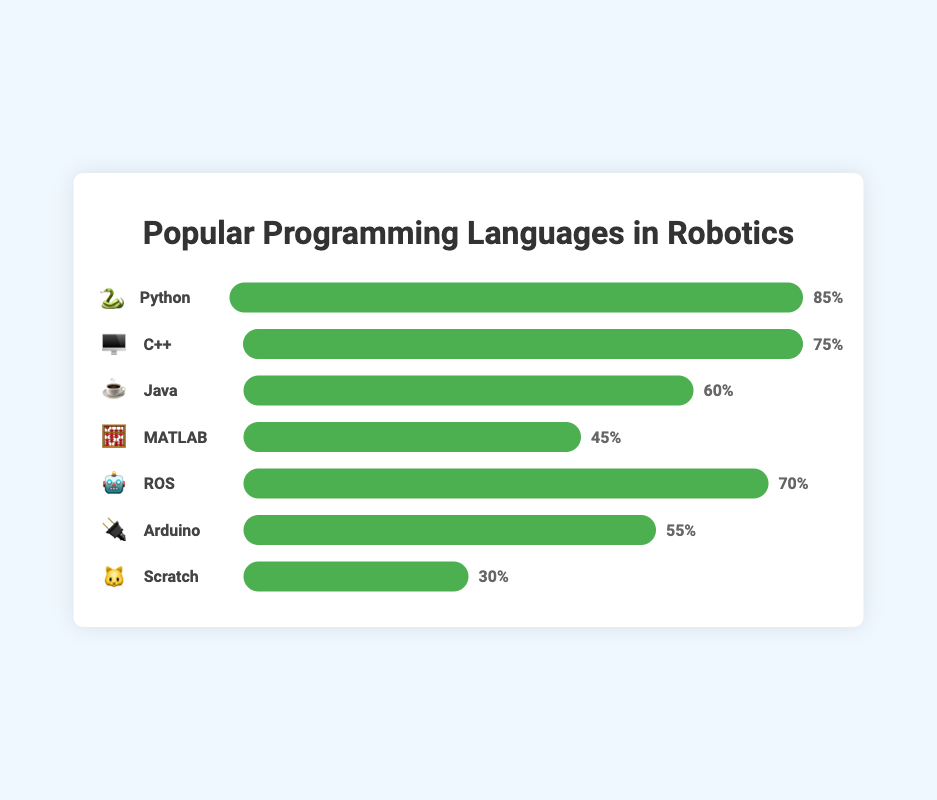Which programming language is represented by a robot emoji 🤖? The programming language represented by the robot emoji 🤖 is 'ROS,' as shown in the chart next to the robot emoji.
Answer: ROS What is the popularity percentage of Python 🐍 in robotics projects? The chart shows that Python 🐍 has a bar indicating a popularity percentage of 85%.
Answer: 85% Which programming language has the highest popularity in robotics projects? By comparing the bars visually, Python 🐍 has the highest popularity with an 85% popularity rate.
Answer: Python How much more popular is C++ 🖥️ compared to MATLAB 🧮? The popularity of C++ 🖥️ is 75%, and MATLAB 🧮 is 45%. The difference is 75% - 45% = 30%.
Answer: 30% Which programming language has the lowest popularity in the chart? The chart shows that Scratch 🐱 has the shortest bar, indicating a 30% popularity, making it the lowest.
Answer: Scratch What's the combined popularity of Java ☕ and Arduino 🔌? The popularity of Java ☕ is 60%, and Arduino 🔌 is 55%. Combined, it's 60% + 55% = 115%.
Answer: 115% How does the popularity of ROS 🤖 compare to Java ☕? The chart shows that ROS 🤖 has a popularity of 70%, while Java ☕ has 60%. ROS 🤖 is 10% more popular than Java ☕.
Answer: 10% more Which programming languages have a popularity above 50%? The bars with over 50% popularity are Python 🐍 (85%), C++ 🖥️ (75%), ROS 🤖 (70%), Java ☕ (60%), and Arduino 🔌 (55%).
Answer: Python, C++, ROS, Java, Arduino What is the average popularity of MATLAB 🧮 and Scratch 🐱? The popularity of MATLAB 🧮 is 45%, and Scratch 🐱 is 30%. The average is (45% + 30%) / 2 = 37.5%.
Answer: 37.5% Is Arduino 🔌 more popular than MATLAB 🧮? Comparing the bars, Arduino 🔌 has a 55% popularity while MATLAB 🧮 has 45%. Thus, Arduino 🔌 is more popular by 10%.
Answer: Yes 